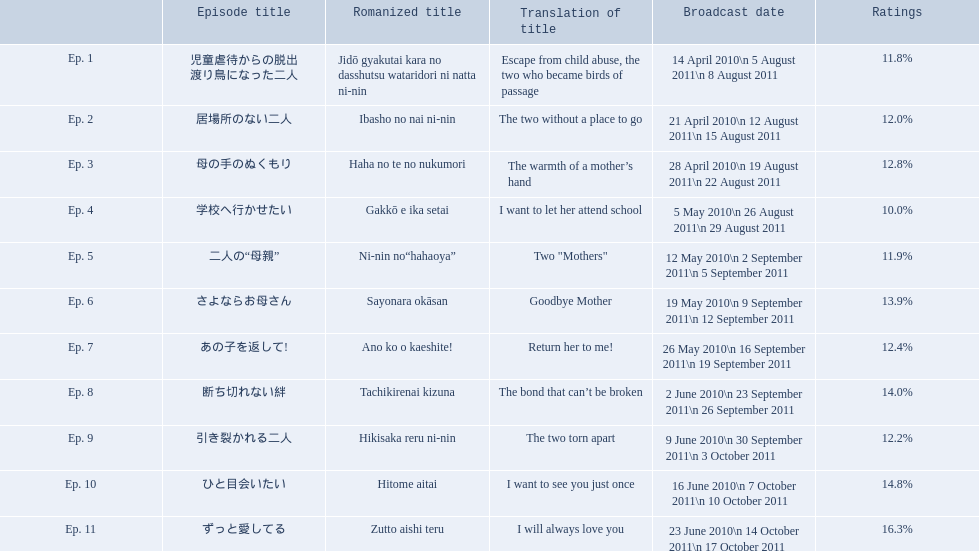What were the installment titles of mother? 児童虐待からの脱出 渡り鳥になった二人, 居場所のない二人, 母の手のぬくもり, 学校へ行かせたい, 二人の“母親”, さよならお母さん, あの子を返して!, 断ち切れない絆, 引き裂かれる二人, ひと目会いたい, ずっと愛してる. Which of these installments had the best ratings? ずっと愛してる. What is the complete sum of episodes? Ep. 1, Ep. 2, Ep. 3, Ep. 4, Ep. 5, Ep. 6, Ep. 7, Ep. 8, Ep. 9, Ep. 10, Ep. 11. Out of those episodes, which one bears the title "the bond that can't be broken"? Ep. 8. What was the ratings percentage for that individual episode? 14.0%. Can you list all the episode titles for the series "mother"? 児童虐待からの脱出 渡り鳥になった二人, 居場所のない二人, 母の手のぬくもり, 学校へ行かせたい, 二人の“母親”, さよならお母さん, あの子を返して!, 断ち切れない絆, 引き裂かれる二人, ひと目会いたい, ずっと愛してる. What are the translated versions of these episode names? Escape from child abuse, the two who became birds of passage, The two without a place to go, The warmth of a mother’s hand, I want to let her attend school, Two "Mothers", Goodbye Mother, Return her to me!, The bond that can’t be broken, The two torn apart, I want to see you just once, I will always love you. Which episode was translated as "i want to let her attend school"? Ep. 4. 